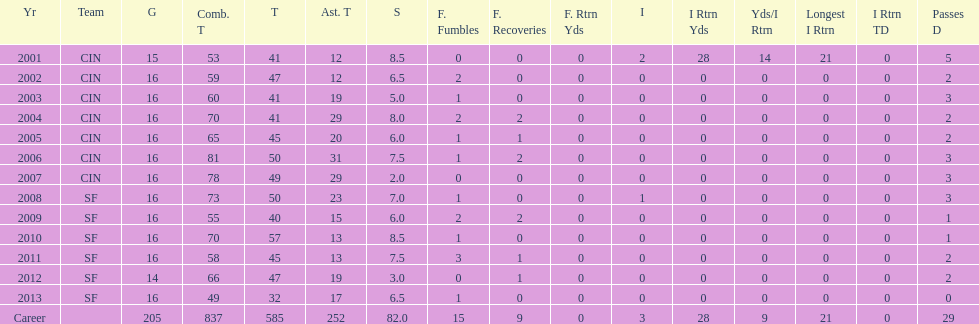How many consecutive years were there 20 or more assisted tackles? 5. 